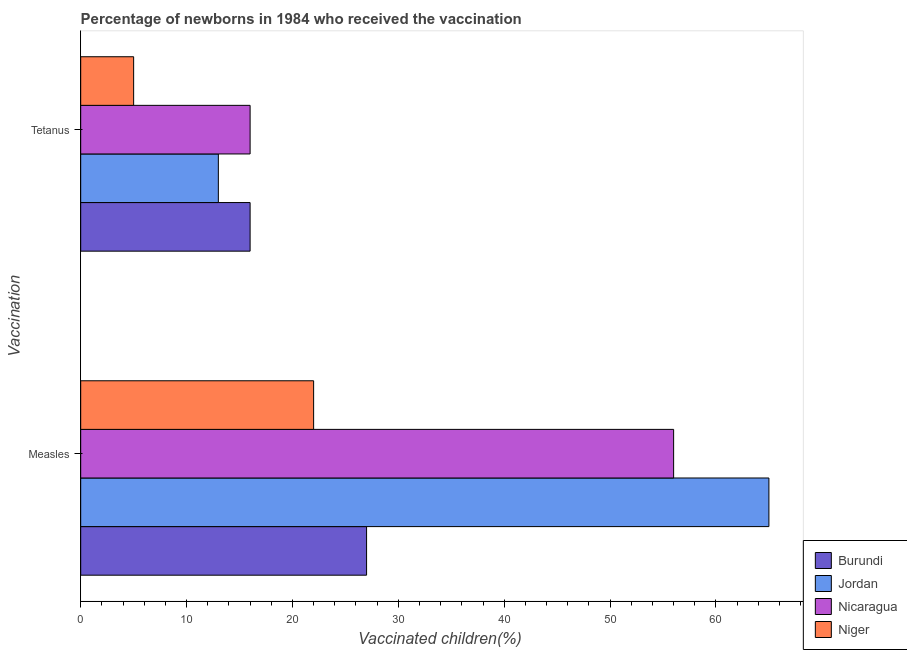How many different coloured bars are there?
Offer a very short reply. 4. How many groups of bars are there?
Keep it short and to the point. 2. Are the number of bars on each tick of the Y-axis equal?
Make the answer very short. Yes. How many bars are there on the 2nd tick from the top?
Offer a terse response. 4. How many bars are there on the 1st tick from the bottom?
Make the answer very short. 4. What is the label of the 2nd group of bars from the top?
Your response must be concise. Measles. What is the percentage of newborns who received vaccination for measles in Burundi?
Your answer should be very brief. 27. Across all countries, what is the maximum percentage of newborns who received vaccination for tetanus?
Your answer should be compact. 16. Across all countries, what is the minimum percentage of newborns who received vaccination for tetanus?
Provide a succinct answer. 5. In which country was the percentage of newborns who received vaccination for tetanus maximum?
Give a very brief answer. Burundi. In which country was the percentage of newborns who received vaccination for tetanus minimum?
Your answer should be compact. Niger. What is the total percentage of newborns who received vaccination for tetanus in the graph?
Your response must be concise. 50. What is the difference between the percentage of newborns who received vaccination for tetanus in Nicaragua and that in Niger?
Keep it short and to the point. 11. What is the difference between the percentage of newborns who received vaccination for tetanus in Nicaragua and the percentage of newborns who received vaccination for measles in Jordan?
Give a very brief answer. -49. What is the difference between the percentage of newborns who received vaccination for measles and percentage of newborns who received vaccination for tetanus in Burundi?
Provide a short and direct response. 11. What is the ratio of the percentage of newborns who received vaccination for tetanus in Nicaragua to that in Burundi?
Your response must be concise. 1. What does the 2nd bar from the top in Tetanus represents?
Your answer should be compact. Nicaragua. What does the 3rd bar from the bottom in Tetanus represents?
Provide a succinct answer. Nicaragua. Does the graph contain any zero values?
Your response must be concise. No. Does the graph contain grids?
Keep it short and to the point. No. How many legend labels are there?
Provide a succinct answer. 4. What is the title of the graph?
Offer a terse response. Percentage of newborns in 1984 who received the vaccination. Does "Lesotho" appear as one of the legend labels in the graph?
Offer a very short reply. No. What is the label or title of the X-axis?
Give a very brief answer. Vaccinated children(%)
. What is the label or title of the Y-axis?
Make the answer very short. Vaccination. What is the Vaccinated children(%)
 of Burundi in Tetanus?
Offer a very short reply. 16. What is the Vaccinated children(%)
 in Jordan in Tetanus?
Ensure brevity in your answer.  13. What is the Vaccinated children(%)
 of Niger in Tetanus?
Provide a short and direct response. 5. Across all Vaccination, what is the maximum Vaccinated children(%)
 of Niger?
Ensure brevity in your answer.  22. Across all Vaccination, what is the minimum Vaccinated children(%)
 in Burundi?
Keep it short and to the point. 16. What is the total Vaccinated children(%)
 of Burundi in the graph?
Give a very brief answer. 43. What is the total Vaccinated children(%)
 in Jordan in the graph?
Provide a short and direct response. 78. What is the difference between the Vaccinated children(%)
 in Niger in Measles and that in Tetanus?
Ensure brevity in your answer.  17. What is the difference between the Vaccinated children(%)
 of Burundi in Measles and the Vaccinated children(%)
 of Jordan in Tetanus?
Make the answer very short. 14. What is the difference between the Vaccinated children(%)
 in Burundi in Measles and the Vaccinated children(%)
 in Niger in Tetanus?
Give a very brief answer. 22. What is the difference between the Vaccinated children(%)
 of Jordan in Measles and the Vaccinated children(%)
 of Niger in Tetanus?
Ensure brevity in your answer.  60. What is the average Vaccinated children(%)
 of Jordan per Vaccination?
Provide a short and direct response. 39. What is the average Vaccinated children(%)
 of Nicaragua per Vaccination?
Offer a terse response. 36. What is the average Vaccinated children(%)
 in Niger per Vaccination?
Your response must be concise. 13.5. What is the difference between the Vaccinated children(%)
 in Burundi and Vaccinated children(%)
 in Jordan in Measles?
Make the answer very short. -38. What is the difference between the Vaccinated children(%)
 of Jordan and Vaccinated children(%)
 of Nicaragua in Measles?
Your response must be concise. 9. What is the difference between the Vaccinated children(%)
 of Jordan and Vaccinated children(%)
 of Niger in Measles?
Offer a very short reply. 43. What is the difference between the Vaccinated children(%)
 of Nicaragua and Vaccinated children(%)
 of Niger in Measles?
Your answer should be compact. 34. What is the difference between the Vaccinated children(%)
 in Burundi and Vaccinated children(%)
 in Nicaragua in Tetanus?
Give a very brief answer. 0. What is the difference between the Vaccinated children(%)
 in Jordan and Vaccinated children(%)
 in Nicaragua in Tetanus?
Offer a terse response. -3. What is the difference between the Vaccinated children(%)
 of Jordan and Vaccinated children(%)
 of Niger in Tetanus?
Provide a succinct answer. 8. What is the ratio of the Vaccinated children(%)
 in Burundi in Measles to that in Tetanus?
Your answer should be very brief. 1.69. What is the ratio of the Vaccinated children(%)
 in Niger in Measles to that in Tetanus?
Make the answer very short. 4.4. What is the difference between the highest and the second highest Vaccinated children(%)
 of Jordan?
Ensure brevity in your answer.  52. What is the difference between the highest and the second highest Vaccinated children(%)
 in Nicaragua?
Your answer should be very brief. 40. What is the difference between the highest and the lowest Vaccinated children(%)
 of Burundi?
Offer a very short reply. 11. What is the difference between the highest and the lowest Vaccinated children(%)
 of Jordan?
Give a very brief answer. 52. What is the difference between the highest and the lowest Vaccinated children(%)
 in Nicaragua?
Provide a succinct answer. 40. 